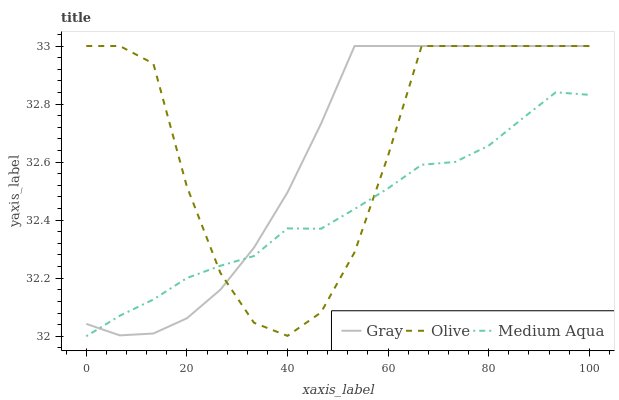Does Gray have the minimum area under the curve?
Answer yes or no. No. Does Gray have the maximum area under the curve?
Answer yes or no. No. Is Gray the smoothest?
Answer yes or no. No. Is Gray the roughest?
Answer yes or no. No. Does Gray have the lowest value?
Answer yes or no. No. Does Medium Aqua have the highest value?
Answer yes or no. No. 